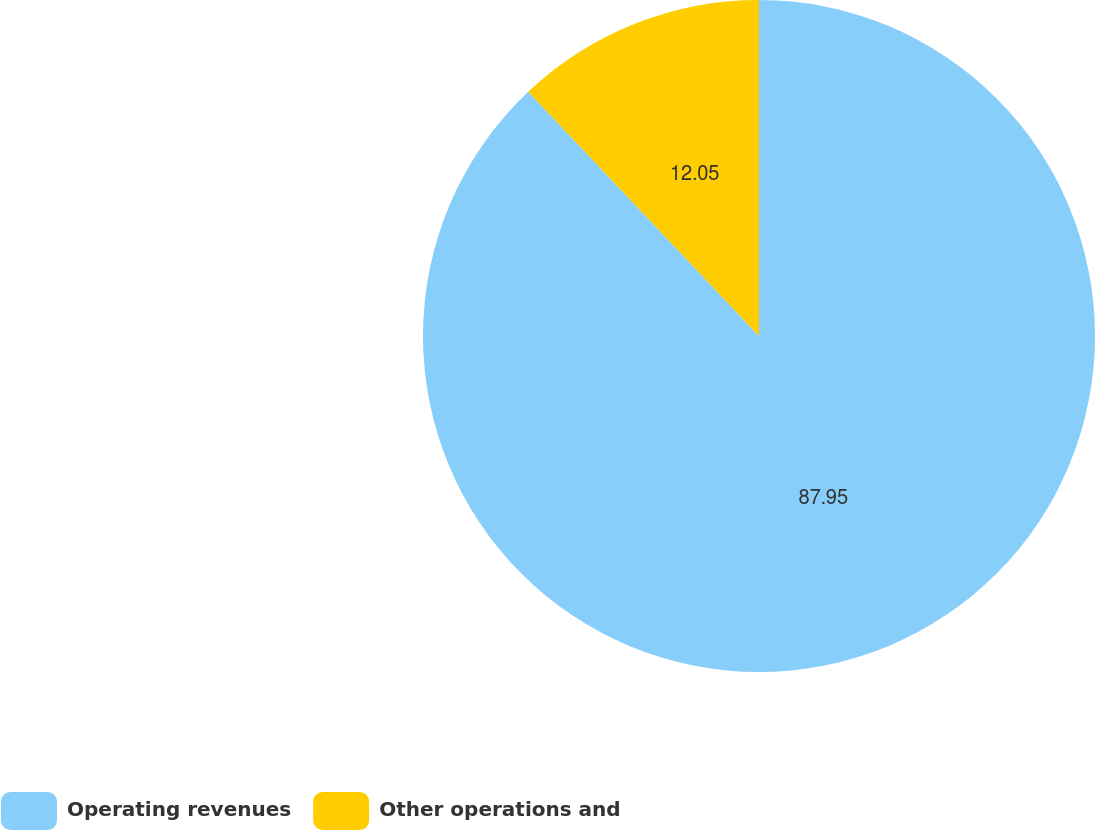<chart> <loc_0><loc_0><loc_500><loc_500><pie_chart><fcel>Operating revenues<fcel>Other operations and<nl><fcel>87.95%<fcel>12.05%<nl></chart> 